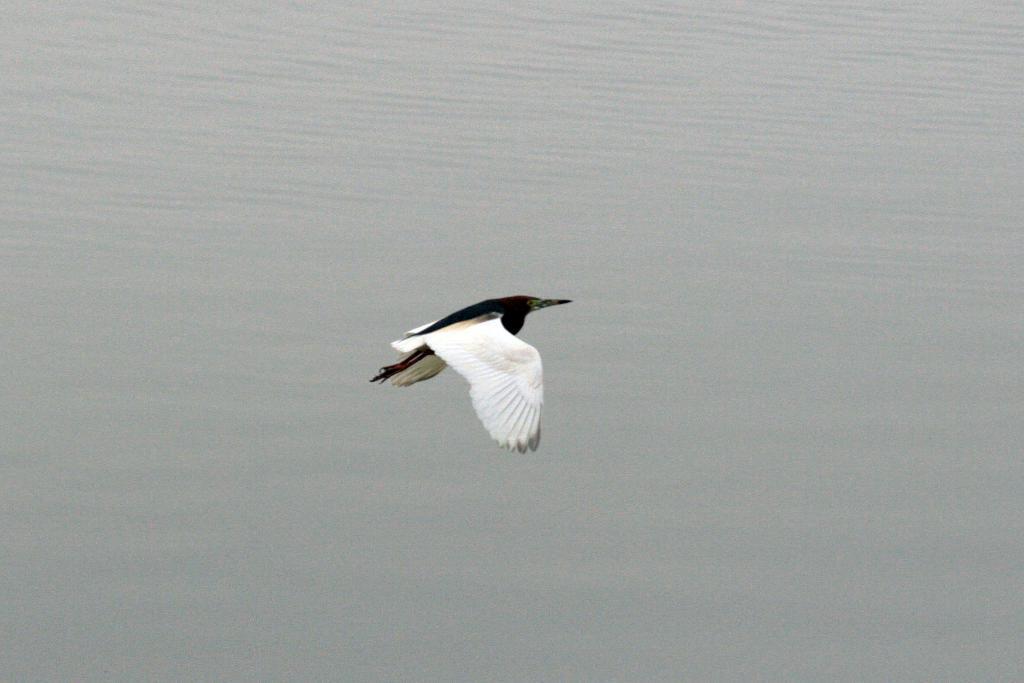Can you describe this image briefly? In this image, this is a bird flying. In the background, I can see the water. 